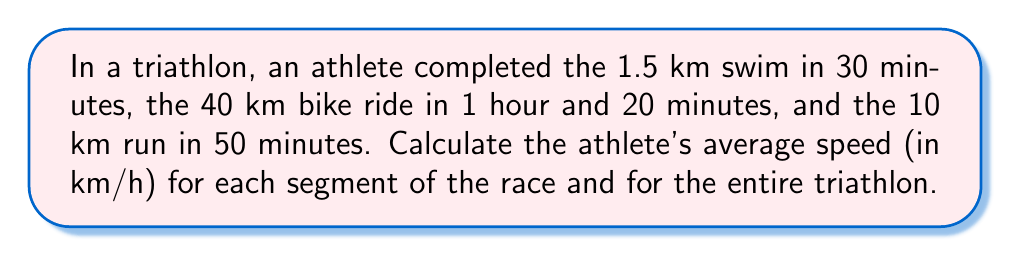Can you answer this question? Let's calculate the average speed for each segment and then for the entire race:

1. Swim segment:
   Distance = 1.5 km, Time = 30 min = 0.5 h
   Average speed = $\frac{\text{Distance}}{\text{Time}} = \frac{1.5 \text{ km}}{0.5 \text{ h}} = 3 \text{ km/h}$

2. Bike segment:
   Distance = 40 km, Time = 1 h 20 min = 1.333... h
   Average speed = $\frac{40 \text{ km}}{1.333... \text{ h}} = 30 \text{ km/h}$

3. Run segment:
   Distance = 10 km, Time = 50 min = 0.833... h
   Average speed = $\frac{10 \text{ km}}{0.833... \text{ h}} = 12 \text{ km/h}$

4. Entire triathlon:
   Total distance = 1.5 + 40 + 10 = 51.5 km
   Total time = 0.5 + 1.333... + 0.833... = 2.666... h
   Average speed = $\frac{51.5 \text{ km}}{2.666... \text{ h}} = 19.3125 \text{ km/h}$

Round the final result to two decimal places: 19.31 km/h
Answer: Swim: 3 km/h, Bike: 30 km/h, Run: 12 km/h, Overall: 19.31 km/h 